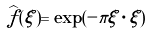Convert formula to latex. <formula><loc_0><loc_0><loc_500><loc_500>\widehat { f } ( \xi ) = \exp ( - \pi \xi \cdot \xi )</formula> 